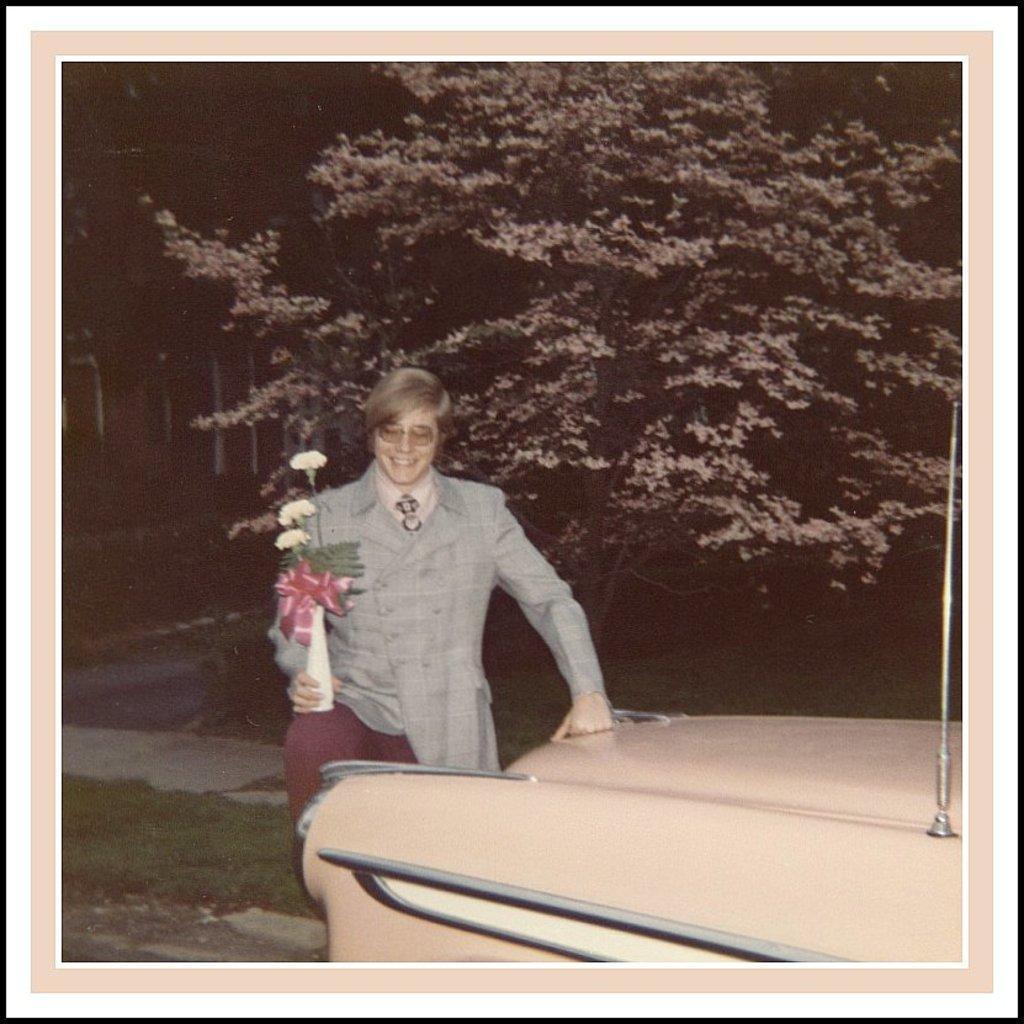In one or two sentences, can you explain what this image depicts? In this image I can see an old photograph in which I can see a person holding a flower vase. I can see a car which is cream in color and in the background I can see few trees. 